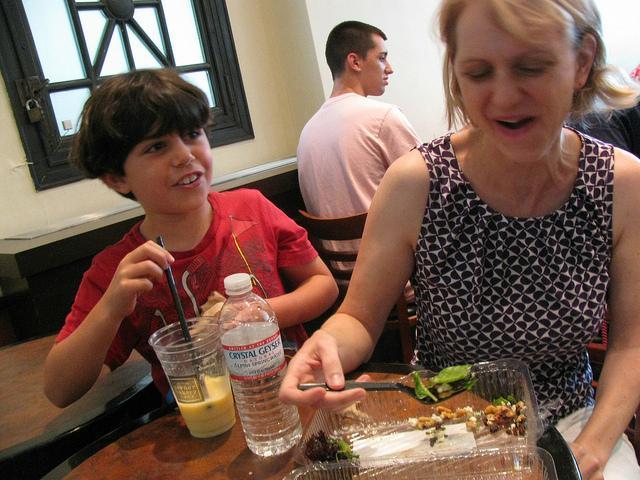How many people do you see?
Give a very brief answer. 3. How many bottles are there?
Give a very brief answer. 1. How many dining tables are there?
Give a very brief answer. 2. How many people can be seen?
Give a very brief answer. 3. 